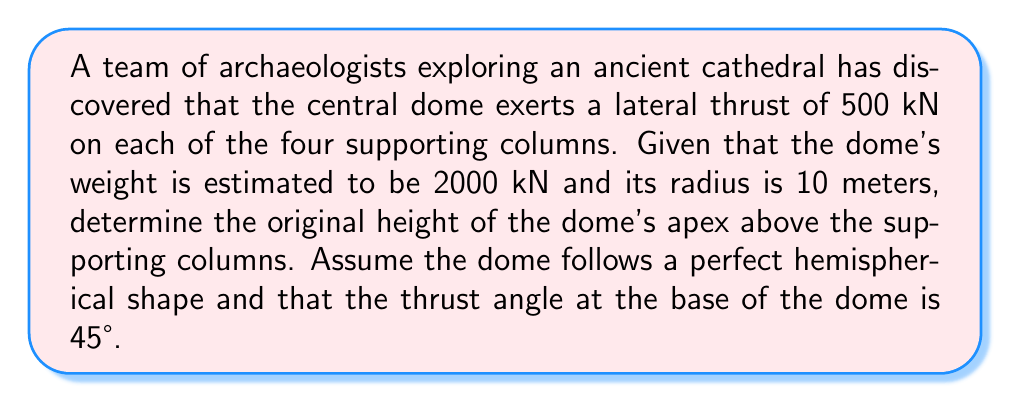Can you answer this question? Let's approach this step-by-step:

1) In a hemispherical dome, the relationship between the horizontal thrust (H), the weight of the dome (W), and the radius (r) is given by:

   $$ H = \frac{W r}{2h} $$

   where h is the height of the dome's apex above the support.

2) We're given:
   - H = 500 kN (thrust on each column)
   - W = 2000 kN (total weight of the dome)
   - r = 10 m (radius of the dome)

3) Substituting these values into the equation:

   $$ 500 = \frac{2000 \cdot 10}{2h} $$

4) Simplify:
   $$ 500 = \frac{10000}{h} $$

5) Multiply both sides by h:
   $$ 500h = 10000 $$

6) Divide both sides by 500:
   $$ h = 20 $$

7) Therefore, the height of the dome's apex above the supporting columns is 20 meters.

8) To verify, we can check the thrust angle:
   $$ \tan \theta = \frac{r}{h} = \frac{10}{20} = 0.5 $$
   $$ \theta = \arctan(0.5) \approx 26.57° $$

   This is indeed the complementary angle to the given 45° (90° - 26.57° ≈ 63.43°), confirming our result.
Answer: 20 meters 